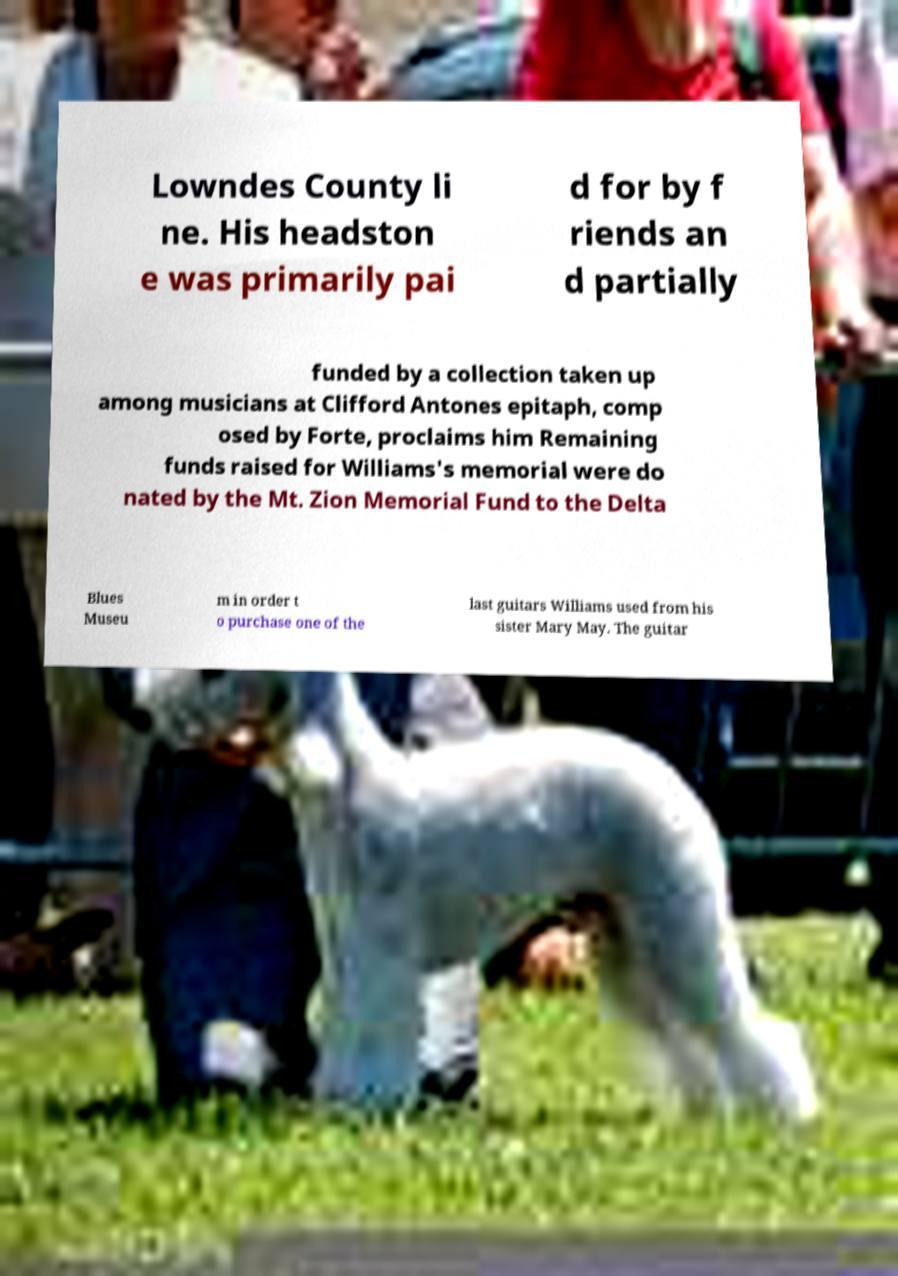I need the written content from this picture converted into text. Can you do that? Lowndes County li ne. His headston e was primarily pai d for by f riends an d partially funded by a collection taken up among musicians at Clifford Antones epitaph, comp osed by Forte, proclaims him Remaining funds raised for Williams's memorial were do nated by the Mt. Zion Memorial Fund to the Delta Blues Museu m in order t o purchase one of the last guitars Williams used from his sister Mary May. The guitar 